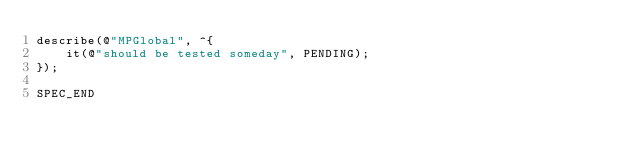<code> <loc_0><loc_0><loc_500><loc_500><_ObjectiveC_>describe(@"MPGlobal", ^{
    it(@"should be tested someday", PENDING);
});

SPEC_END
</code> 